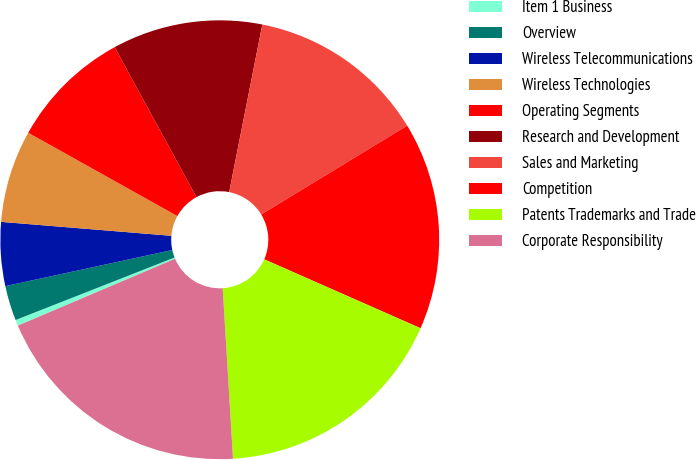<chart> <loc_0><loc_0><loc_500><loc_500><pie_chart><fcel>Item 1 Business<fcel>Overview<fcel>Wireless Telecommunications<fcel>Wireless Technologies<fcel>Operating Segments<fcel>Research and Development<fcel>Sales and Marketing<fcel>Competition<fcel>Patents Trademarks and Trade<fcel>Corporate Responsibility<nl><fcel>0.44%<fcel>2.57%<fcel>4.69%<fcel>6.81%<fcel>8.94%<fcel>11.06%<fcel>13.19%<fcel>15.31%<fcel>17.43%<fcel>19.56%<nl></chart> 